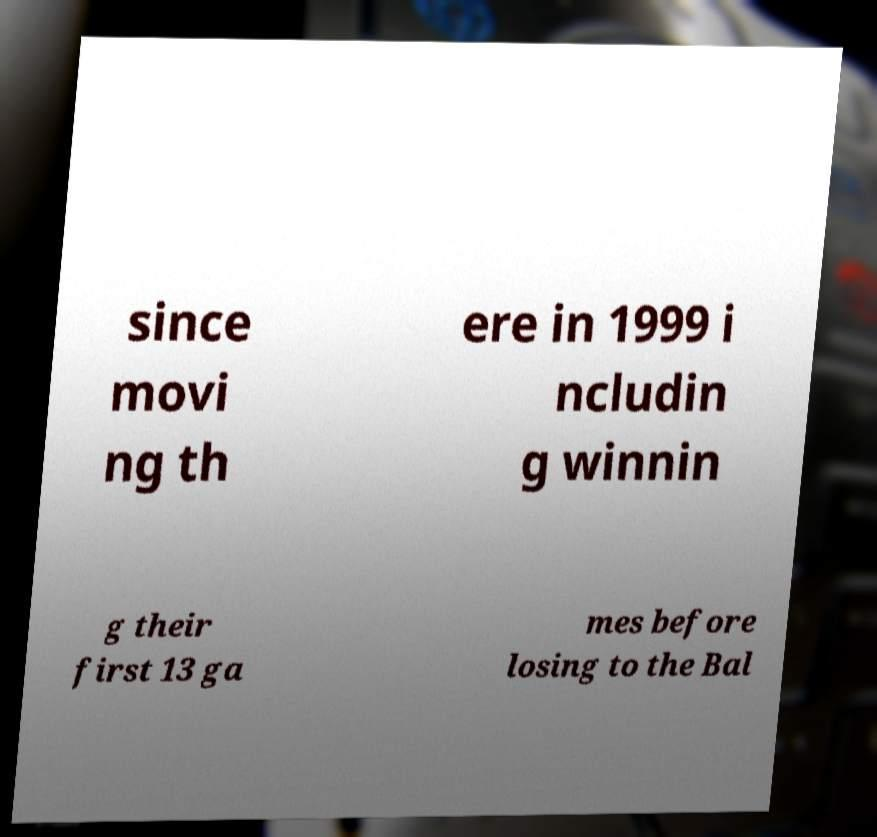Can you accurately transcribe the text from the provided image for me? since movi ng th ere in 1999 i ncludin g winnin g their first 13 ga mes before losing to the Bal 